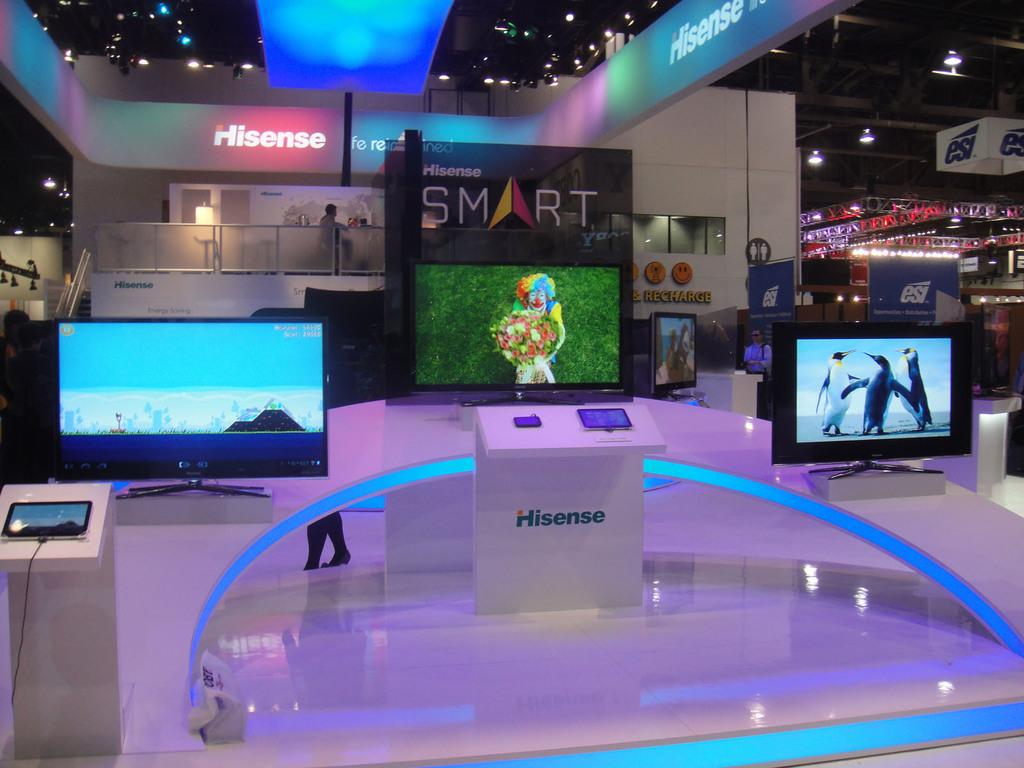<image>
Create a compact narrative representing the image presented. a sign that has the word smart on it in a room 